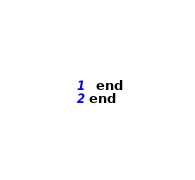<code> <loc_0><loc_0><loc_500><loc_500><_Ruby_>  end
end
</code> 